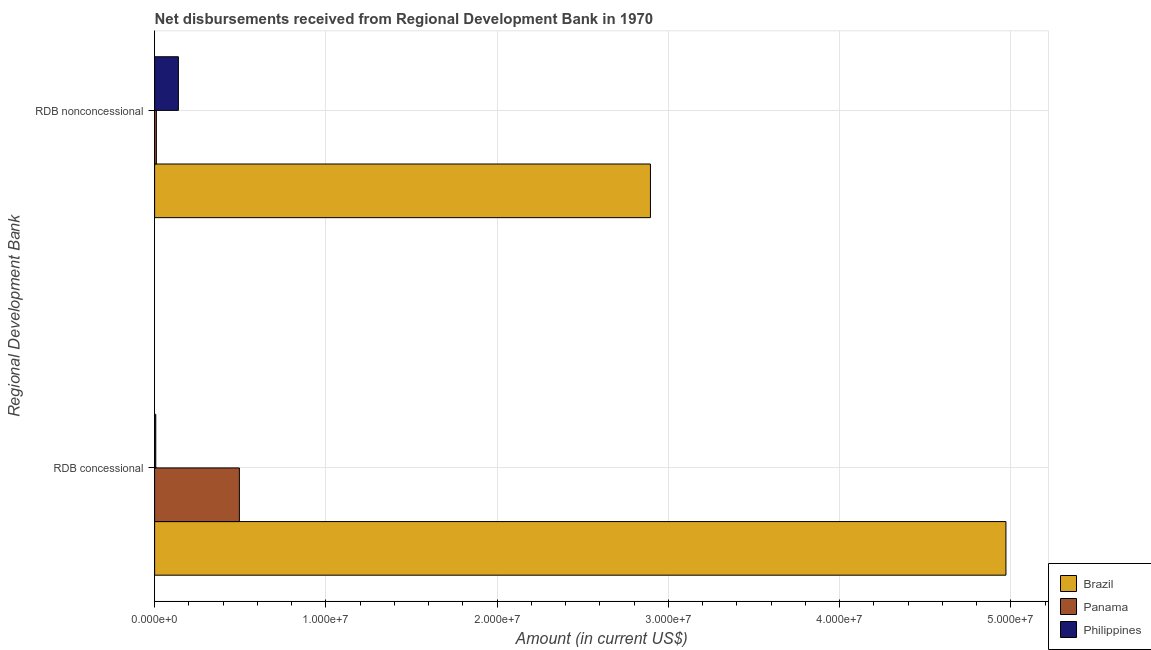Are the number of bars per tick equal to the number of legend labels?
Provide a succinct answer. Yes. Are the number of bars on each tick of the Y-axis equal?
Keep it short and to the point. Yes. How many bars are there on the 2nd tick from the bottom?
Your response must be concise. 3. What is the label of the 2nd group of bars from the top?
Offer a very short reply. RDB concessional. What is the net non concessional disbursements from rdb in Philippines?
Your response must be concise. 1.39e+06. Across all countries, what is the maximum net concessional disbursements from rdb?
Offer a very short reply. 4.97e+07. Across all countries, what is the minimum net concessional disbursements from rdb?
Make the answer very short. 6.90e+04. In which country was the net non concessional disbursements from rdb maximum?
Offer a very short reply. Brazil. In which country was the net concessional disbursements from rdb minimum?
Ensure brevity in your answer.  Philippines. What is the total net non concessional disbursements from rdb in the graph?
Provide a succinct answer. 3.04e+07. What is the difference between the net non concessional disbursements from rdb in Brazil and that in Panama?
Your answer should be compact. 2.88e+07. What is the difference between the net concessional disbursements from rdb in Philippines and the net non concessional disbursements from rdb in Panama?
Offer a terse response. -3.40e+04. What is the average net non concessional disbursements from rdb per country?
Your answer should be very brief. 1.01e+07. What is the difference between the net concessional disbursements from rdb and net non concessional disbursements from rdb in Philippines?
Ensure brevity in your answer.  -1.32e+06. In how many countries, is the net concessional disbursements from rdb greater than 44000000 US$?
Ensure brevity in your answer.  1. What is the ratio of the net concessional disbursements from rdb in Panama to that in Brazil?
Ensure brevity in your answer.  0.1. Is the net concessional disbursements from rdb in Philippines less than that in Panama?
Your response must be concise. Yes. In how many countries, is the net non concessional disbursements from rdb greater than the average net non concessional disbursements from rdb taken over all countries?
Your response must be concise. 1. What does the 2nd bar from the top in RDB nonconcessional represents?
Provide a short and direct response. Panama. How many countries are there in the graph?
Keep it short and to the point. 3. What is the difference between two consecutive major ticks on the X-axis?
Keep it short and to the point. 1.00e+07. Are the values on the major ticks of X-axis written in scientific E-notation?
Offer a terse response. Yes. Does the graph contain grids?
Offer a very short reply. Yes. Where does the legend appear in the graph?
Provide a short and direct response. Bottom right. How many legend labels are there?
Keep it short and to the point. 3. How are the legend labels stacked?
Make the answer very short. Vertical. What is the title of the graph?
Keep it short and to the point. Net disbursements received from Regional Development Bank in 1970. What is the label or title of the X-axis?
Your answer should be very brief. Amount (in current US$). What is the label or title of the Y-axis?
Give a very brief answer. Regional Development Bank. What is the Amount (in current US$) of Brazil in RDB concessional?
Your answer should be very brief. 4.97e+07. What is the Amount (in current US$) in Panama in RDB concessional?
Give a very brief answer. 4.95e+06. What is the Amount (in current US$) in Philippines in RDB concessional?
Your answer should be compact. 6.90e+04. What is the Amount (in current US$) in Brazil in RDB nonconcessional?
Offer a very short reply. 2.90e+07. What is the Amount (in current US$) of Panama in RDB nonconcessional?
Provide a short and direct response. 1.03e+05. What is the Amount (in current US$) in Philippines in RDB nonconcessional?
Give a very brief answer. 1.39e+06. Across all Regional Development Bank, what is the maximum Amount (in current US$) in Brazil?
Ensure brevity in your answer.  4.97e+07. Across all Regional Development Bank, what is the maximum Amount (in current US$) of Panama?
Provide a short and direct response. 4.95e+06. Across all Regional Development Bank, what is the maximum Amount (in current US$) in Philippines?
Make the answer very short. 1.39e+06. Across all Regional Development Bank, what is the minimum Amount (in current US$) of Brazil?
Provide a succinct answer. 2.90e+07. Across all Regional Development Bank, what is the minimum Amount (in current US$) in Panama?
Provide a short and direct response. 1.03e+05. Across all Regional Development Bank, what is the minimum Amount (in current US$) in Philippines?
Keep it short and to the point. 6.90e+04. What is the total Amount (in current US$) in Brazil in the graph?
Keep it short and to the point. 7.87e+07. What is the total Amount (in current US$) of Panama in the graph?
Offer a very short reply. 5.05e+06. What is the total Amount (in current US$) in Philippines in the graph?
Offer a terse response. 1.46e+06. What is the difference between the Amount (in current US$) in Brazil in RDB concessional and that in RDB nonconcessional?
Keep it short and to the point. 2.08e+07. What is the difference between the Amount (in current US$) of Panama in RDB concessional and that in RDB nonconcessional?
Your answer should be very brief. 4.85e+06. What is the difference between the Amount (in current US$) of Philippines in RDB concessional and that in RDB nonconcessional?
Offer a terse response. -1.32e+06. What is the difference between the Amount (in current US$) of Brazil in RDB concessional and the Amount (in current US$) of Panama in RDB nonconcessional?
Your answer should be very brief. 4.96e+07. What is the difference between the Amount (in current US$) of Brazil in RDB concessional and the Amount (in current US$) of Philippines in RDB nonconcessional?
Make the answer very short. 4.83e+07. What is the difference between the Amount (in current US$) in Panama in RDB concessional and the Amount (in current US$) in Philippines in RDB nonconcessional?
Ensure brevity in your answer.  3.56e+06. What is the average Amount (in current US$) in Brazil per Regional Development Bank?
Give a very brief answer. 3.93e+07. What is the average Amount (in current US$) of Panama per Regional Development Bank?
Your answer should be very brief. 2.53e+06. What is the average Amount (in current US$) of Philippines per Regional Development Bank?
Ensure brevity in your answer.  7.29e+05. What is the difference between the Amount (in current US$) in Brazil and Amount (in current US$) in Panama in RDB concessional?
Your answer should be very brief. 4.48e+07. What is the difference between the Amount (in current US$) in Brazil and Amount (in current US$) in Philippines in RDB concessional?
Give a very brief answer. 4.96e+07. What is the difference between the Amount (in current US$) of Panama and Amount (in current US$) of Philippines in RDB concessional?
Provide a succinct answer. 4.88e+06. What is the difference between the Amount (in current US$) in Brazil and Amount (in current US$) in Panama in RDB nonconcessional?
Make the answer very short. 2.88e+07. What is the difference between the Amount (in current US$) in Brazil and Amount (in current US$) in Philippines in RDB nonconcessional?
Your answer should be very brief. 2.76e+07. What is the difference between the Amount (in current US$) of Panama and Amount (in current US$) of Philippines in RDB nonconcessional?
Offer a terse response. -1.29e+06. What is the ratio of the Amount (in current US$) in Brazil in RDB concessional to that in RDB nonconcessional?
Ensure brevity in your answer.  1.72. What is the ratio of the Amount (in current US$) in Panama in RDB concessional to that in RDB nonconcessional?
Give a very brief answer. 48.06. What is the ratio of the Amount (in current US$) in Philippines in RDB concessional to that in RDB nonconcessional?
Make the answer very short. 0.05. What is the difference between the highest and the second highest Amount (in current US$) in Brazil?
Offer a very short reply. 2.08e+07. What is the difference between the highest and the second highest Amount (in current US$) in Panama?
Your answer should be compact. 4.85e+06. What is the difference between the highest and the second highest Amount (in current US$) in Philippines?
Your answer should be compact. 1.32e+06. What is the difference between the highest and the lowest Amount (in current US$) in Brazil?
Ensure brevity in your answer.  2.08e+07. What is the difference between the highest and the lowest Amount (in current US$) of Panama?
Provide a succinct answer. 4.85e+06. What is the difference between the highest and the lowest Amount (in current US$) of Philippines?
Your response must be concise. 1.32e+06. 